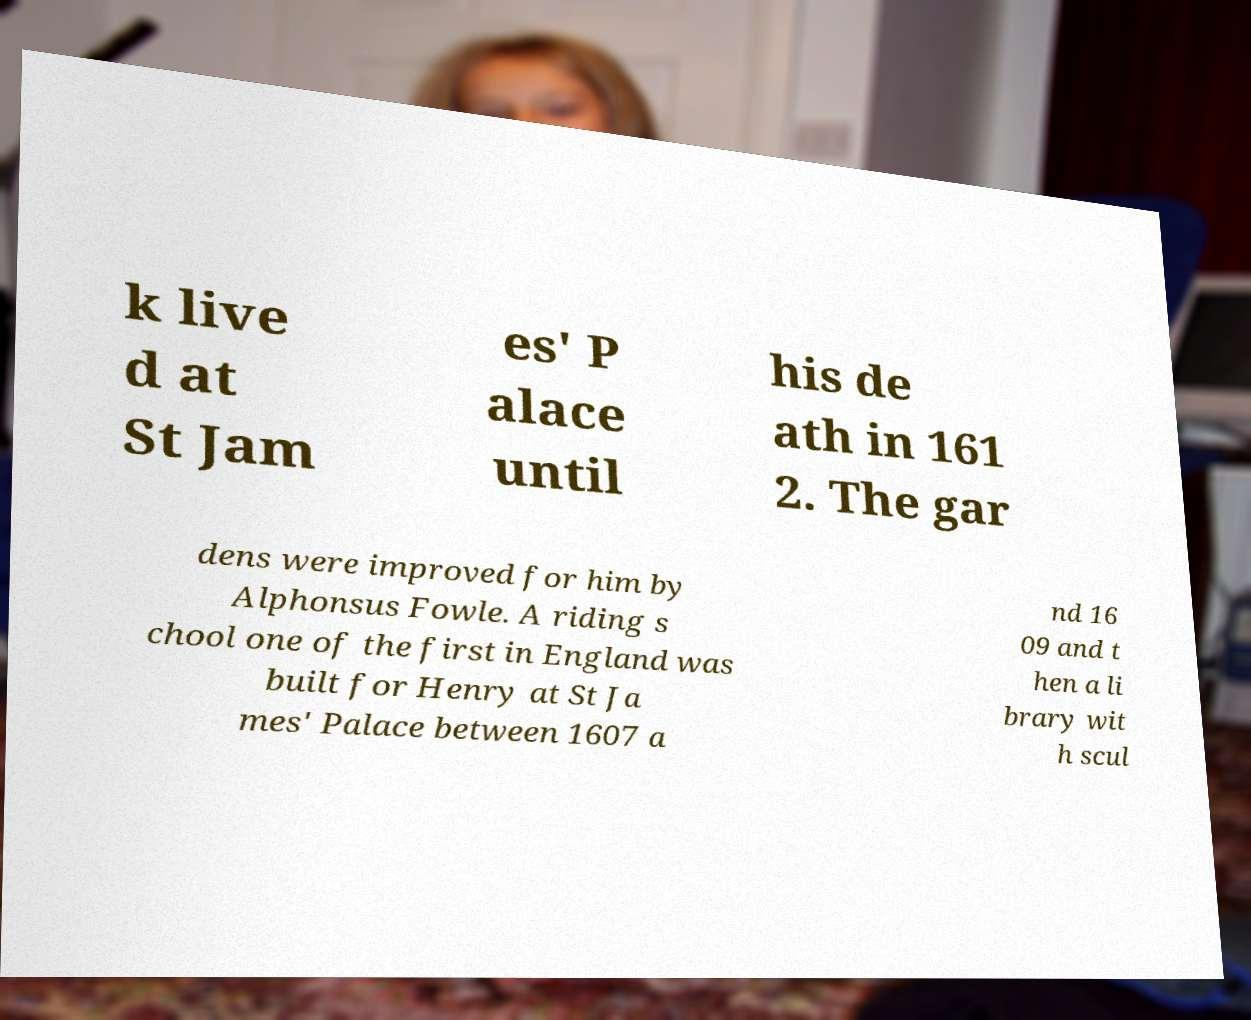Could you assist in decoding the text presented in this image and type it out clearly? k live d at St Jam es' P alace until his de ath in 161 2. The gar dens were improved for him by Alphonsus Fowle. A riding s chool one of the first in England was built for Henry at St Ja mes' Palace between 1607 a nd 16 09 and t hen a li brary wit h scul 